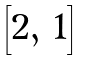<formula> <loc_0><loc_0><loc_500><loc_500>\begin{bmatrix} 2 , \, 1 \end{bmatrix}</formula> 